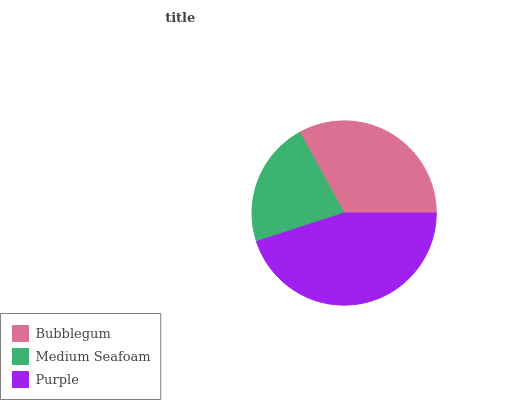Is Medium Seafoam the minimum?
Answer yes or no. Yes. Is Purple the maximum?
Answer yes or no. Yes. Is Purple the minimum?
Answer yes or no. No. Is Medium Seafoam the maximum?
Answer yes or no. No. Is Purple greater than Medium Seafoam?
Answer yes or no. Yes. Is Medium Seafoam less than Purple?
Answer yes or no. Yes. Is Medium Seafoam greater than Purple?
Answer yes or no. No. Is Purple less than Medium Seafoam?
Answer yes or no. No. Is Bubblegum the high median?
Answer yes or no. Yes. Is Bubblegum the low median?
Answer yes or no. Yes. Is Purple the high median?
Answer yes or no. No. Is Medium Seafoam the low median?
Answer yes or no. No. 